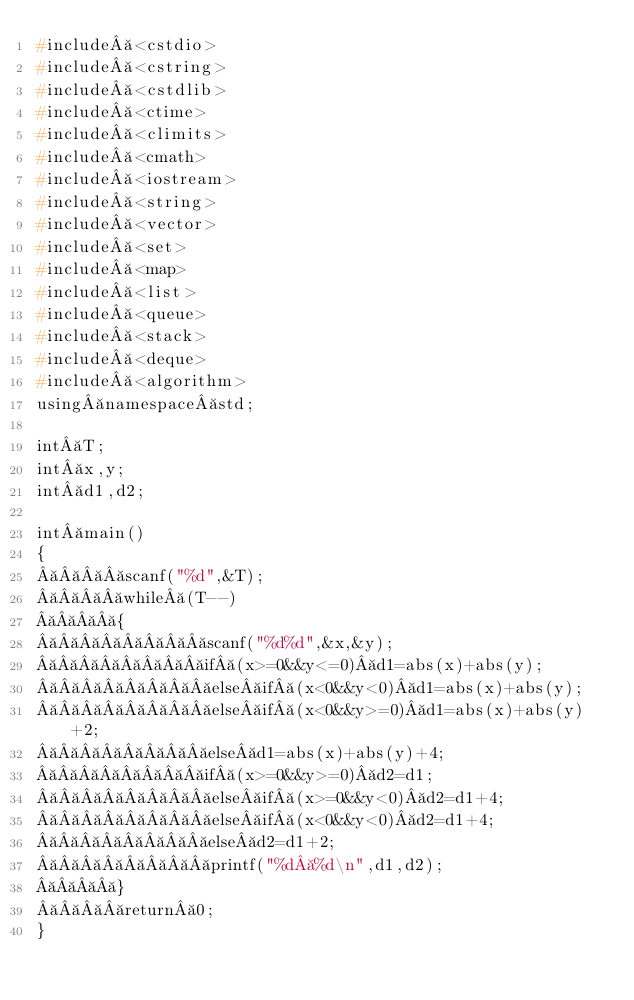<code> <loc_0><loc_0><loc_500><loc_500><_C++_>#include <cstdio>
#include <cstring>
#include <cstdlib>
#include <ctime>
#include <climits>
#include <cmath>
#include <iostream>
#include <string>
#include <vector>
#include <set>
#include <map>
#include <list>
#include <queue>
#include <stack>
#include <deque>
#include <algorithm>
using namespace std;

int T;
int x,y;
int d1,d2;

int main()
{
    scanf("%d",&T);
    while (T--)
    {
        scanf("%d%d",&x,&y);
        if (x>=0&&y<=0) d1=abs(x)+abs(y);
        else if (x<0&&y<0) d1=abs(x)+abs(y);
        else if (x<0&&y>=0) d1=abs(x)+abs(y)+2;
        else d1=abs(x)+abs(y)+4;
        if (x>=0&&y>=0) d2=d1;
        else if (x>=0&&y<0) d2=d1+4;
        else if (x<0&&y<0) d2=d1+4;
        else d2=d1+2;
        printf("%d %d\n",d1,d2);
    }
    return 0;
}
</code> 